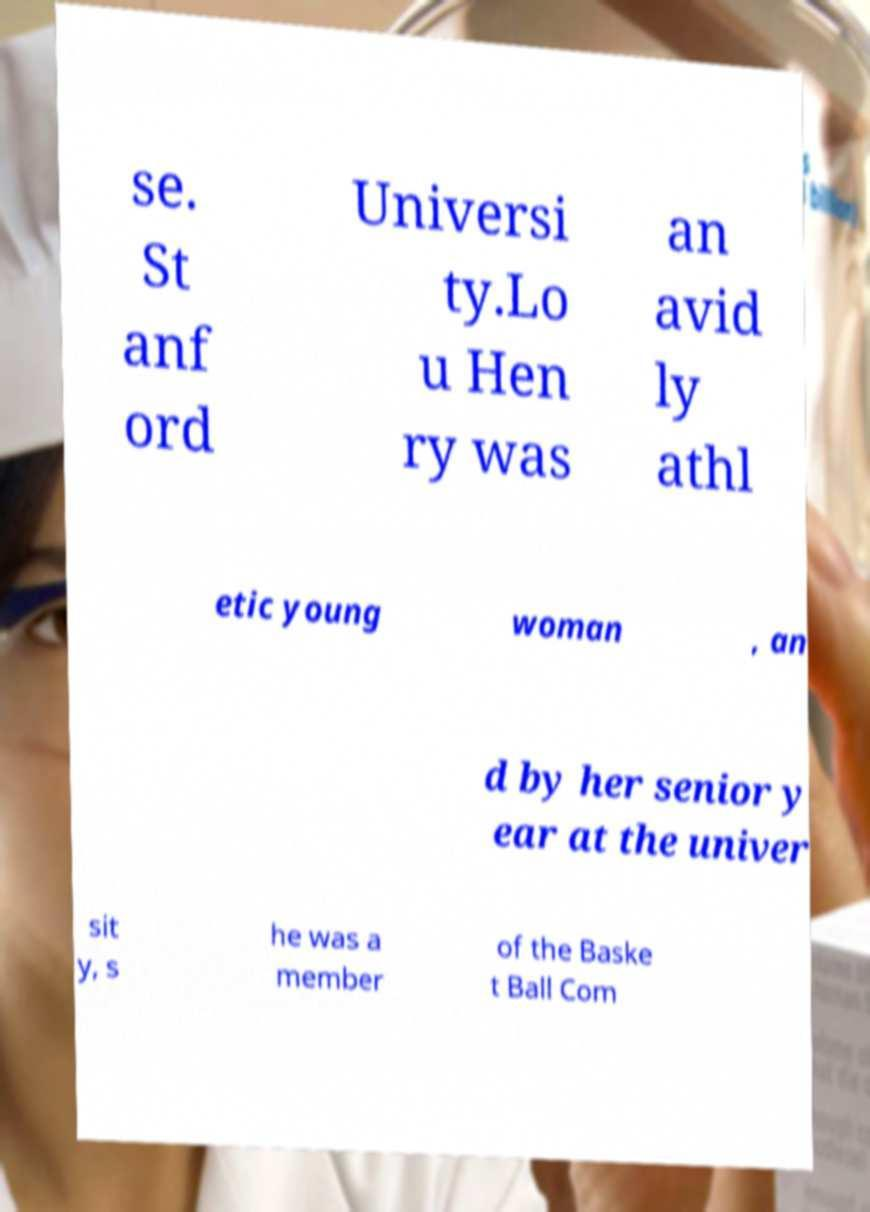For documentation purposes, I need the text within this image transcribed. Could you provide that? se. St anf ord Universi ty.Lo u Hen ry was an avid ly athl etic young woman , an d by her senior y ear at the univer sit y, s he was a member of the Baske t Ball Com 